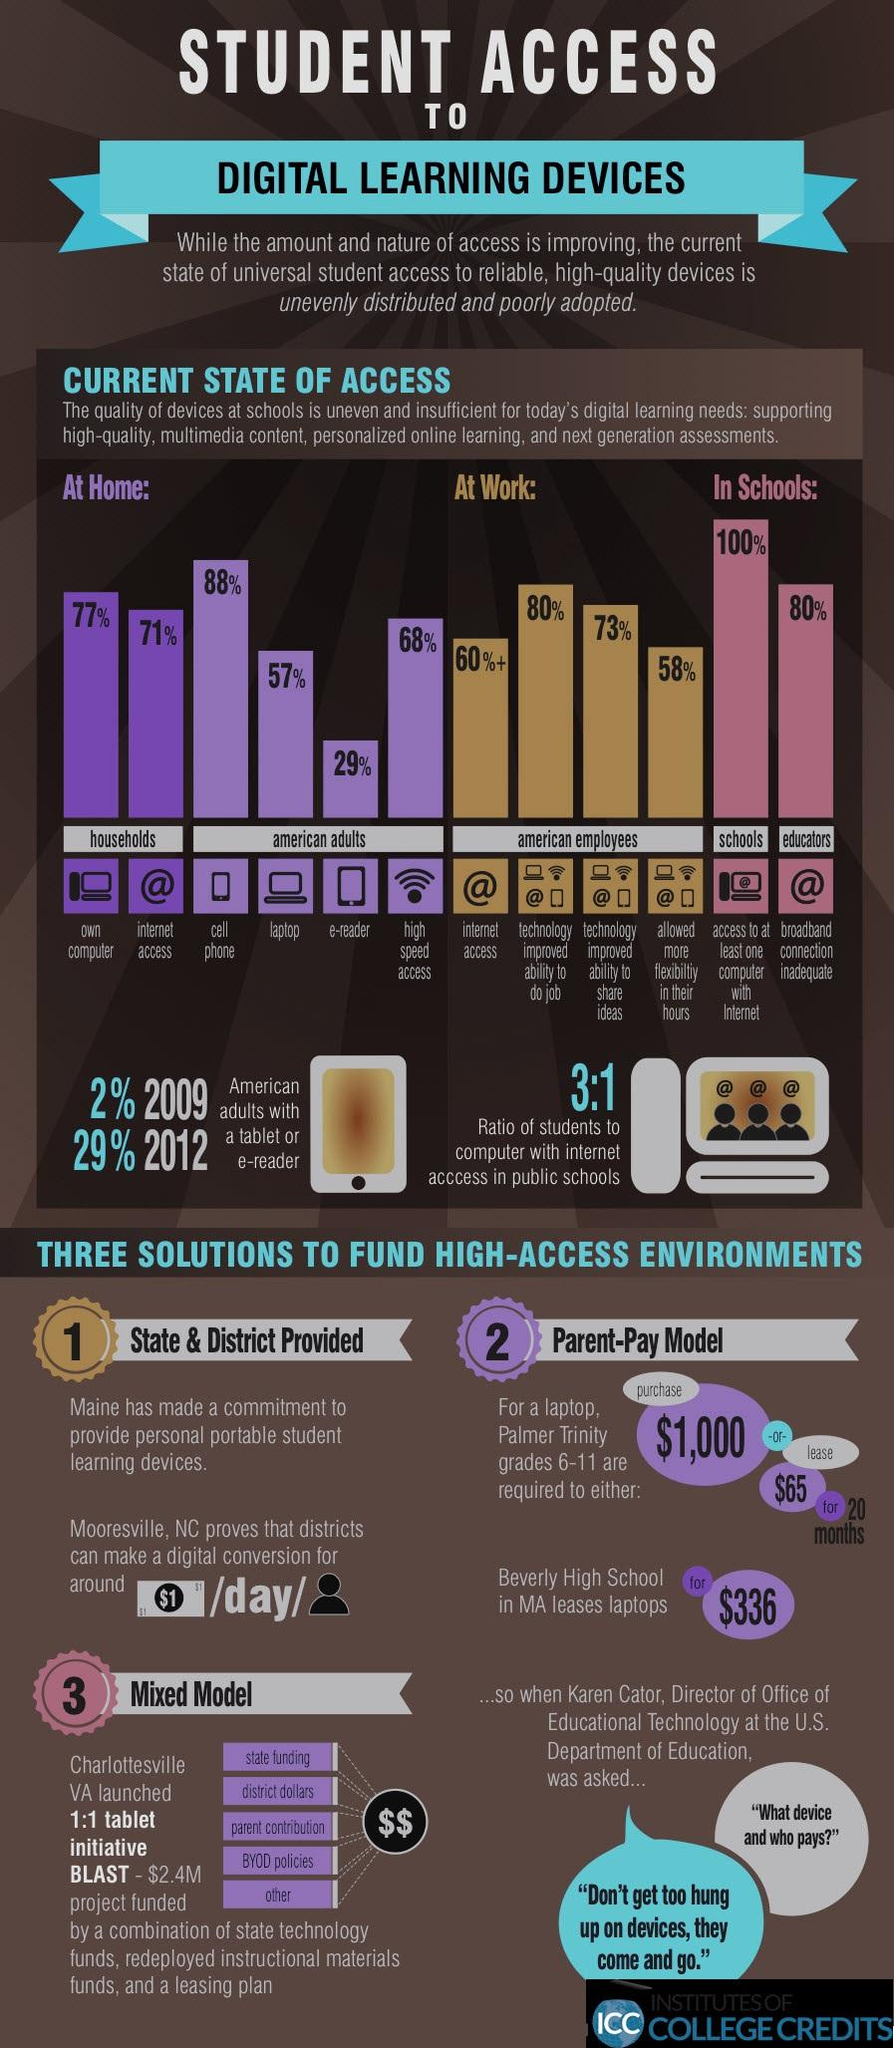Identify some key points in this picture. Sixty-eight percent of American adults have access to high-speed WiFi at home. A staggering 80% of educators in America are currently experiencing inadequate broadband connections, significantly hindering their ability to provide students with the high-quality digital learning experiences they deserve. All American schools have access to at least one computer with internet, indicating that 100% of schools meet this criterion. According to recent statistics, 77% of households in America own a computer. It is estimated that over 60% of American employees have access to the internet. 